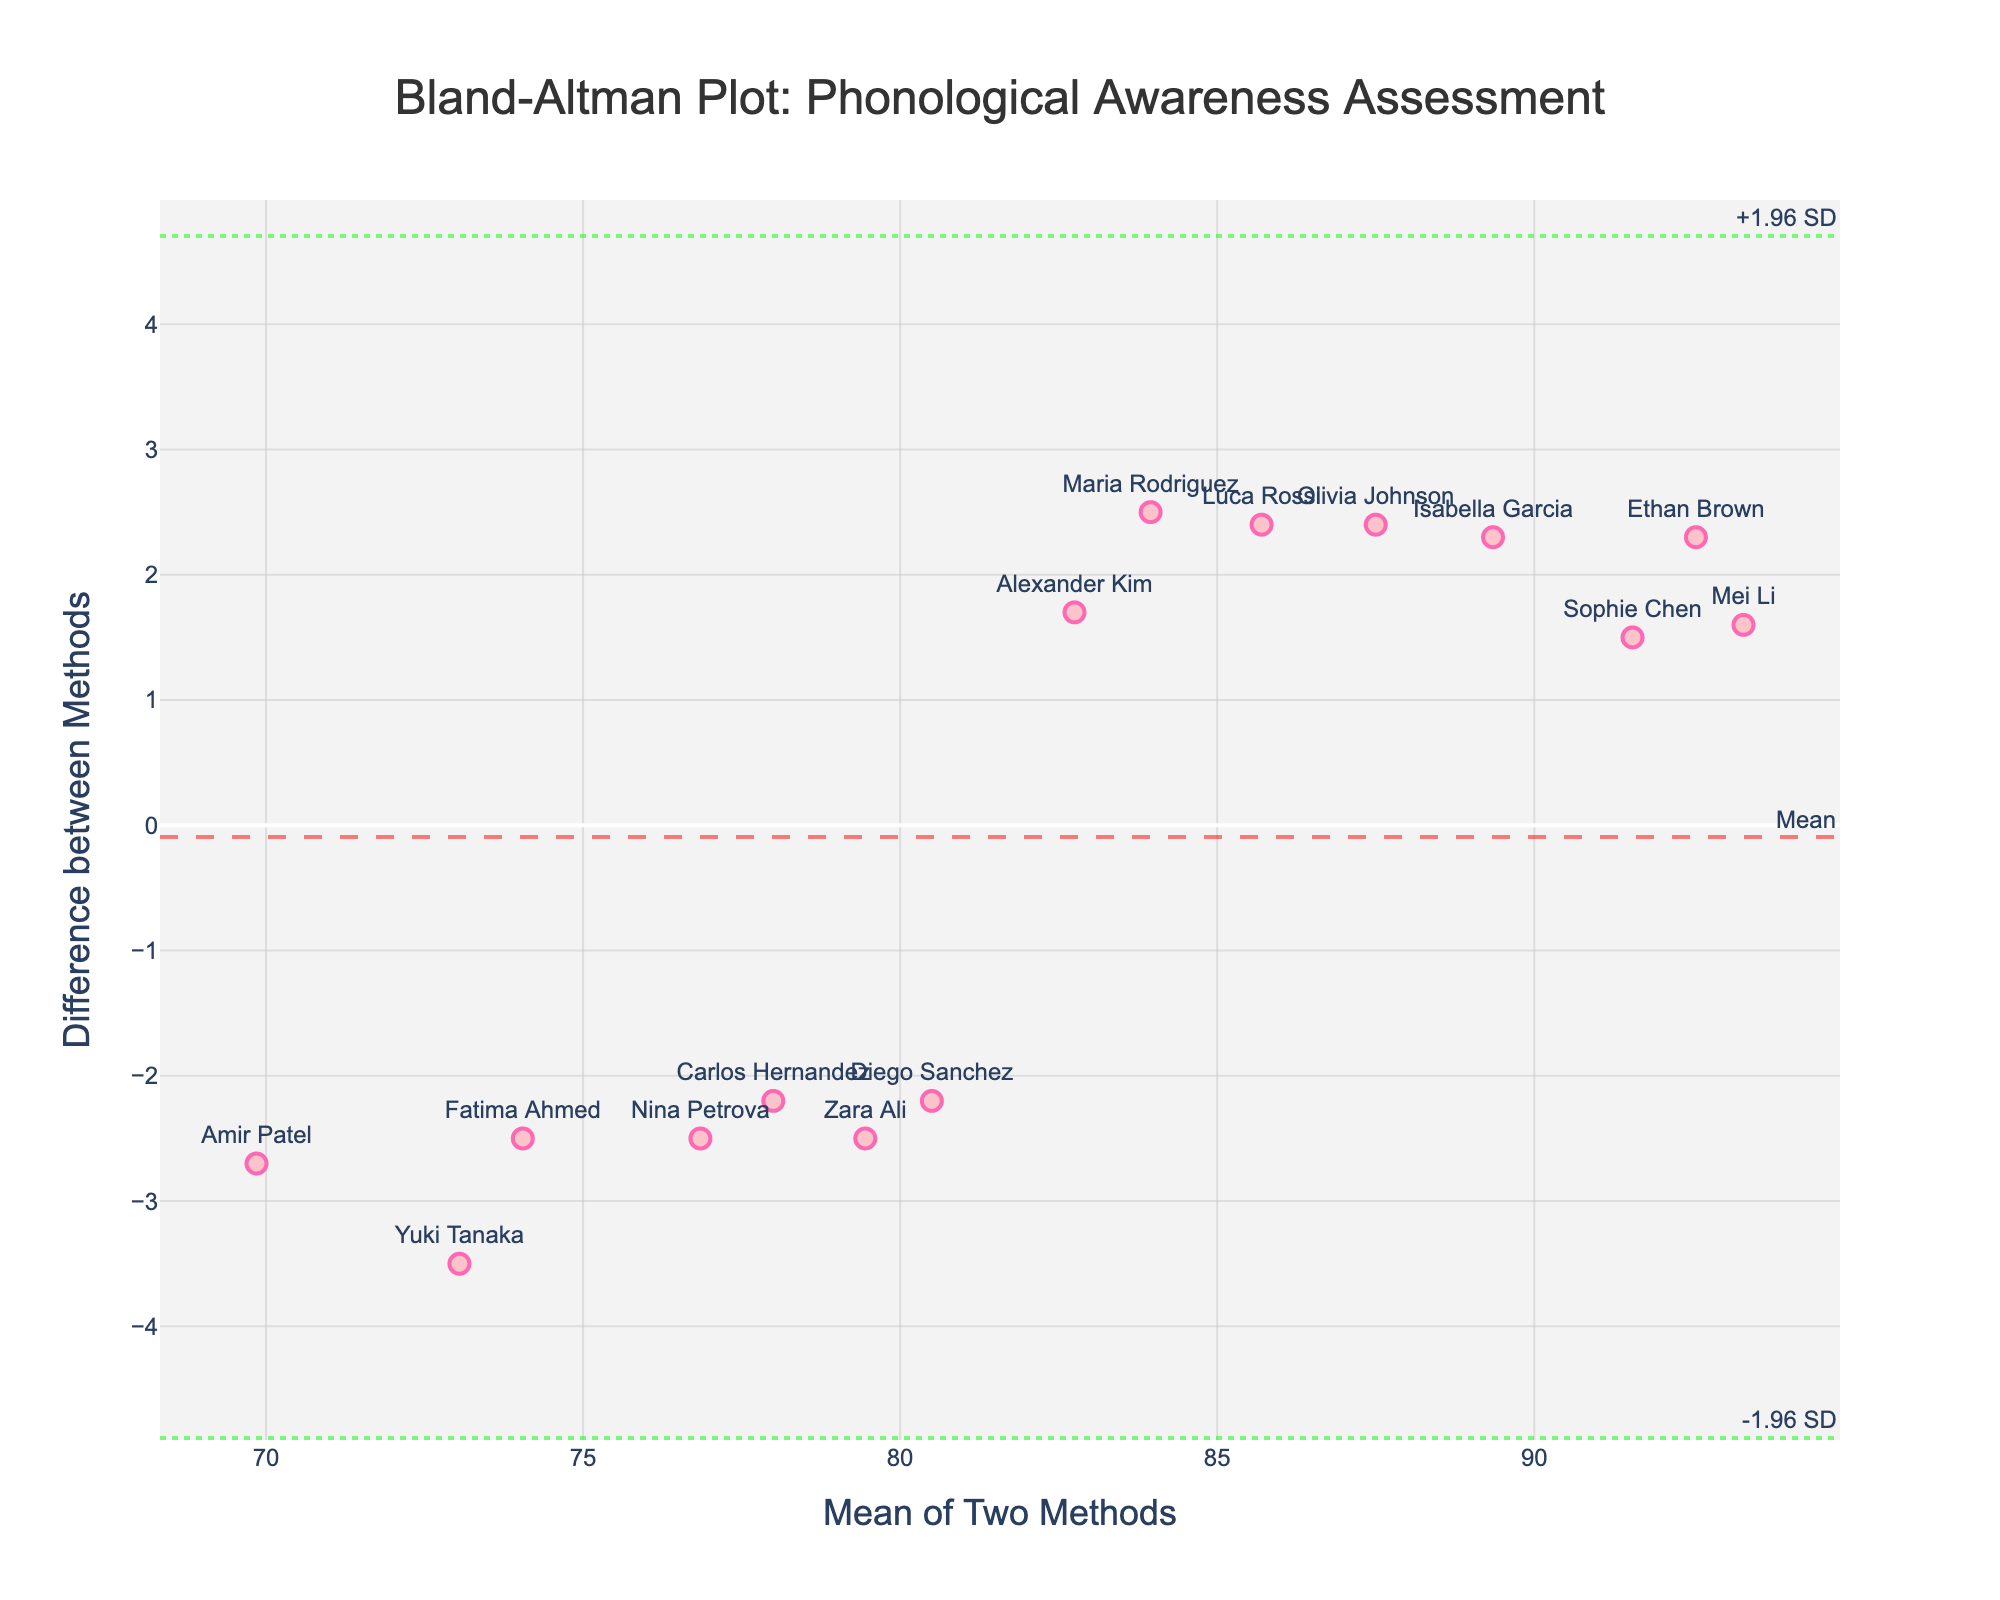What is the title of the plot? The title of the plot is written at the top and often represents the key focus of the plot, in this case, it's "Bland-Altman Plot: Phonological Awareness Assessment"
Answer: Bland-Altman Plot: Phonological Awareness Assessment What do the x and y axes represent? The x-axis title is "Mean of Two Methods," which indicates the average score from both Method1 and Method2. The y-axis title is "Difference between Methods," signaling the difference in scores between the two methods.
Answer: Mean of Two Methods; Difference between Methods How many data points are displayed in the plot? Each subject has one data point represented by a marker on the plot. Counting these markers reveals the total number of data points. Since there are 15 subjects listed in the provided data, there are 15 data points.
Answer: 15 Which subject has the highest mean value of the two methods? To identify this, locate the highest x-axis value on the plot and refer to the corresponding subject label.
Answer: Mei Li What is the mean difference between the two methods? This information is depicted by the horizontal dashed line labeled "Mean" on the plot. The y-coordinate of this horizontal line is the mean difference.
Answer: 2.00 What subject shows the largest positive difference between the two methods? To find this, we look at the data point furthest above the x-axis on the y-scale, then reference the corresponding subject label.
Answer: Nina Petrova What are the upper and lower limits of agreement on this plot? The limits of agreement are represented by the dotted horizontal lines labeled "+1.96 SD" and "-1.96 SD". The y-coordinates of these lines represent the upper and lower limits.
Answer: +6.85 and -2.85 Which subject has the smallest difference between the two methods? Find the data point that is closest to the x-axis (y = 0) and reference the corresponding subject label.
Answer: Sophia Chen How does the spread of differences change across the range of means? To assess the spread, observe whether data points are more dispersed or clustered along the x-axis (mean values). If points spread evenly, the difference is consistent across the range; if clusters appear, the spread changes.
Answer: Relatively consistent From which subject is the largest negative difference observed? The largest negative difference is the data point furthest below the x-axis, and its corresponding subject label tells which subject it is.
Answer: Luca Rossi 